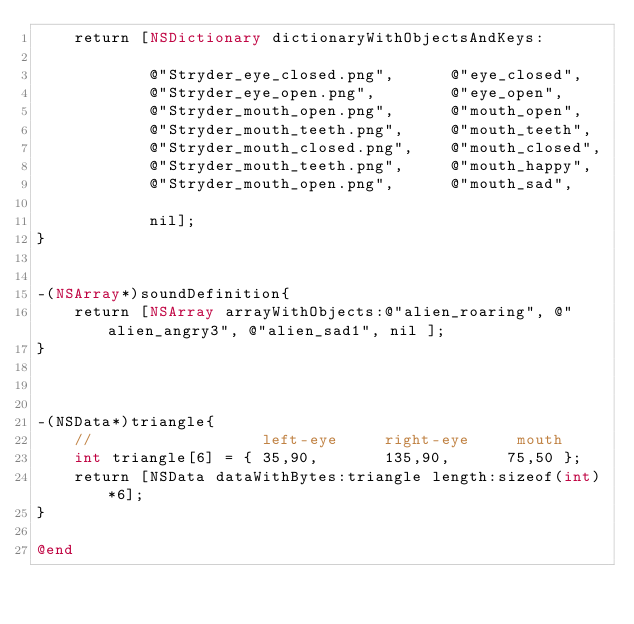<code> <loc_0><loc_0><loc_500><loc_500><_ObjectiveC_>	return [NSDictionary dictionaryWithObjectsAndKeys:
			
			@"Stryder_eye_closed.png",		@"eye_closed",
			@"Stryder_eye_open.png",		@"eye_open",
			@"Stryder_mouth_open.png",		@"mouth_open",
			@"Stryder_mouth_teeth.png",		@"mouth_teeth",
			@"Stryder_mouth_closed.png",	@"mouth_closed",
			@"Stryder_mouth_teeth.png",		@"mouth_happy",
			@"Stryder_mouth_open.png",		@"mouth_sad",
			
			nil];
}


-(NSArray*)soundDefinition{	
	return [NSArray arrayWithObjects:@"alien_roaring", @"alien_angry3", @"alien_sad1", nil ];
}



-(NSData*)triangle{
	//				    left-eye     right-eye     mouth
	int triangle[6]	= { 35,90,       135,90,      75,50 };
	return [NSData dataWithBytes:triangle length:sizeof(int)*6];
}

@end
</code> 